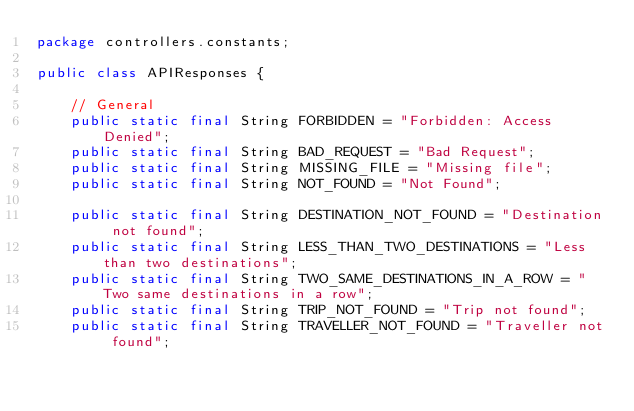<code> <loc_0><loc_0><loc_500><loc_500><_Java_>package controllers.constants;

public class APIResponses {

    // General
    public static final String FORBIDDEN = "Forbidden: Access Denied";
    public static final String BAD_REQUEST = "Bad Request";
    public static final String MISSING_FILE = "Missing file";
    public static final String NOT_FOUND = "Not Found";

    public static final String DESTINATION_NOT_FOUND = "Destination not found";
    public static final String LESS_THAN_TWO_DESTINATIONS = "Less than two destinations";
    public static final String TWO_SAME_DESTINATIONS_IN_A_ROW = "Two same destinations in a row";
    public static final String TRIP_NOT_FOUND = "Trip not found";
    public static final String TRAVELLER_NOT_FOUND = "Traveller not found";</code> 